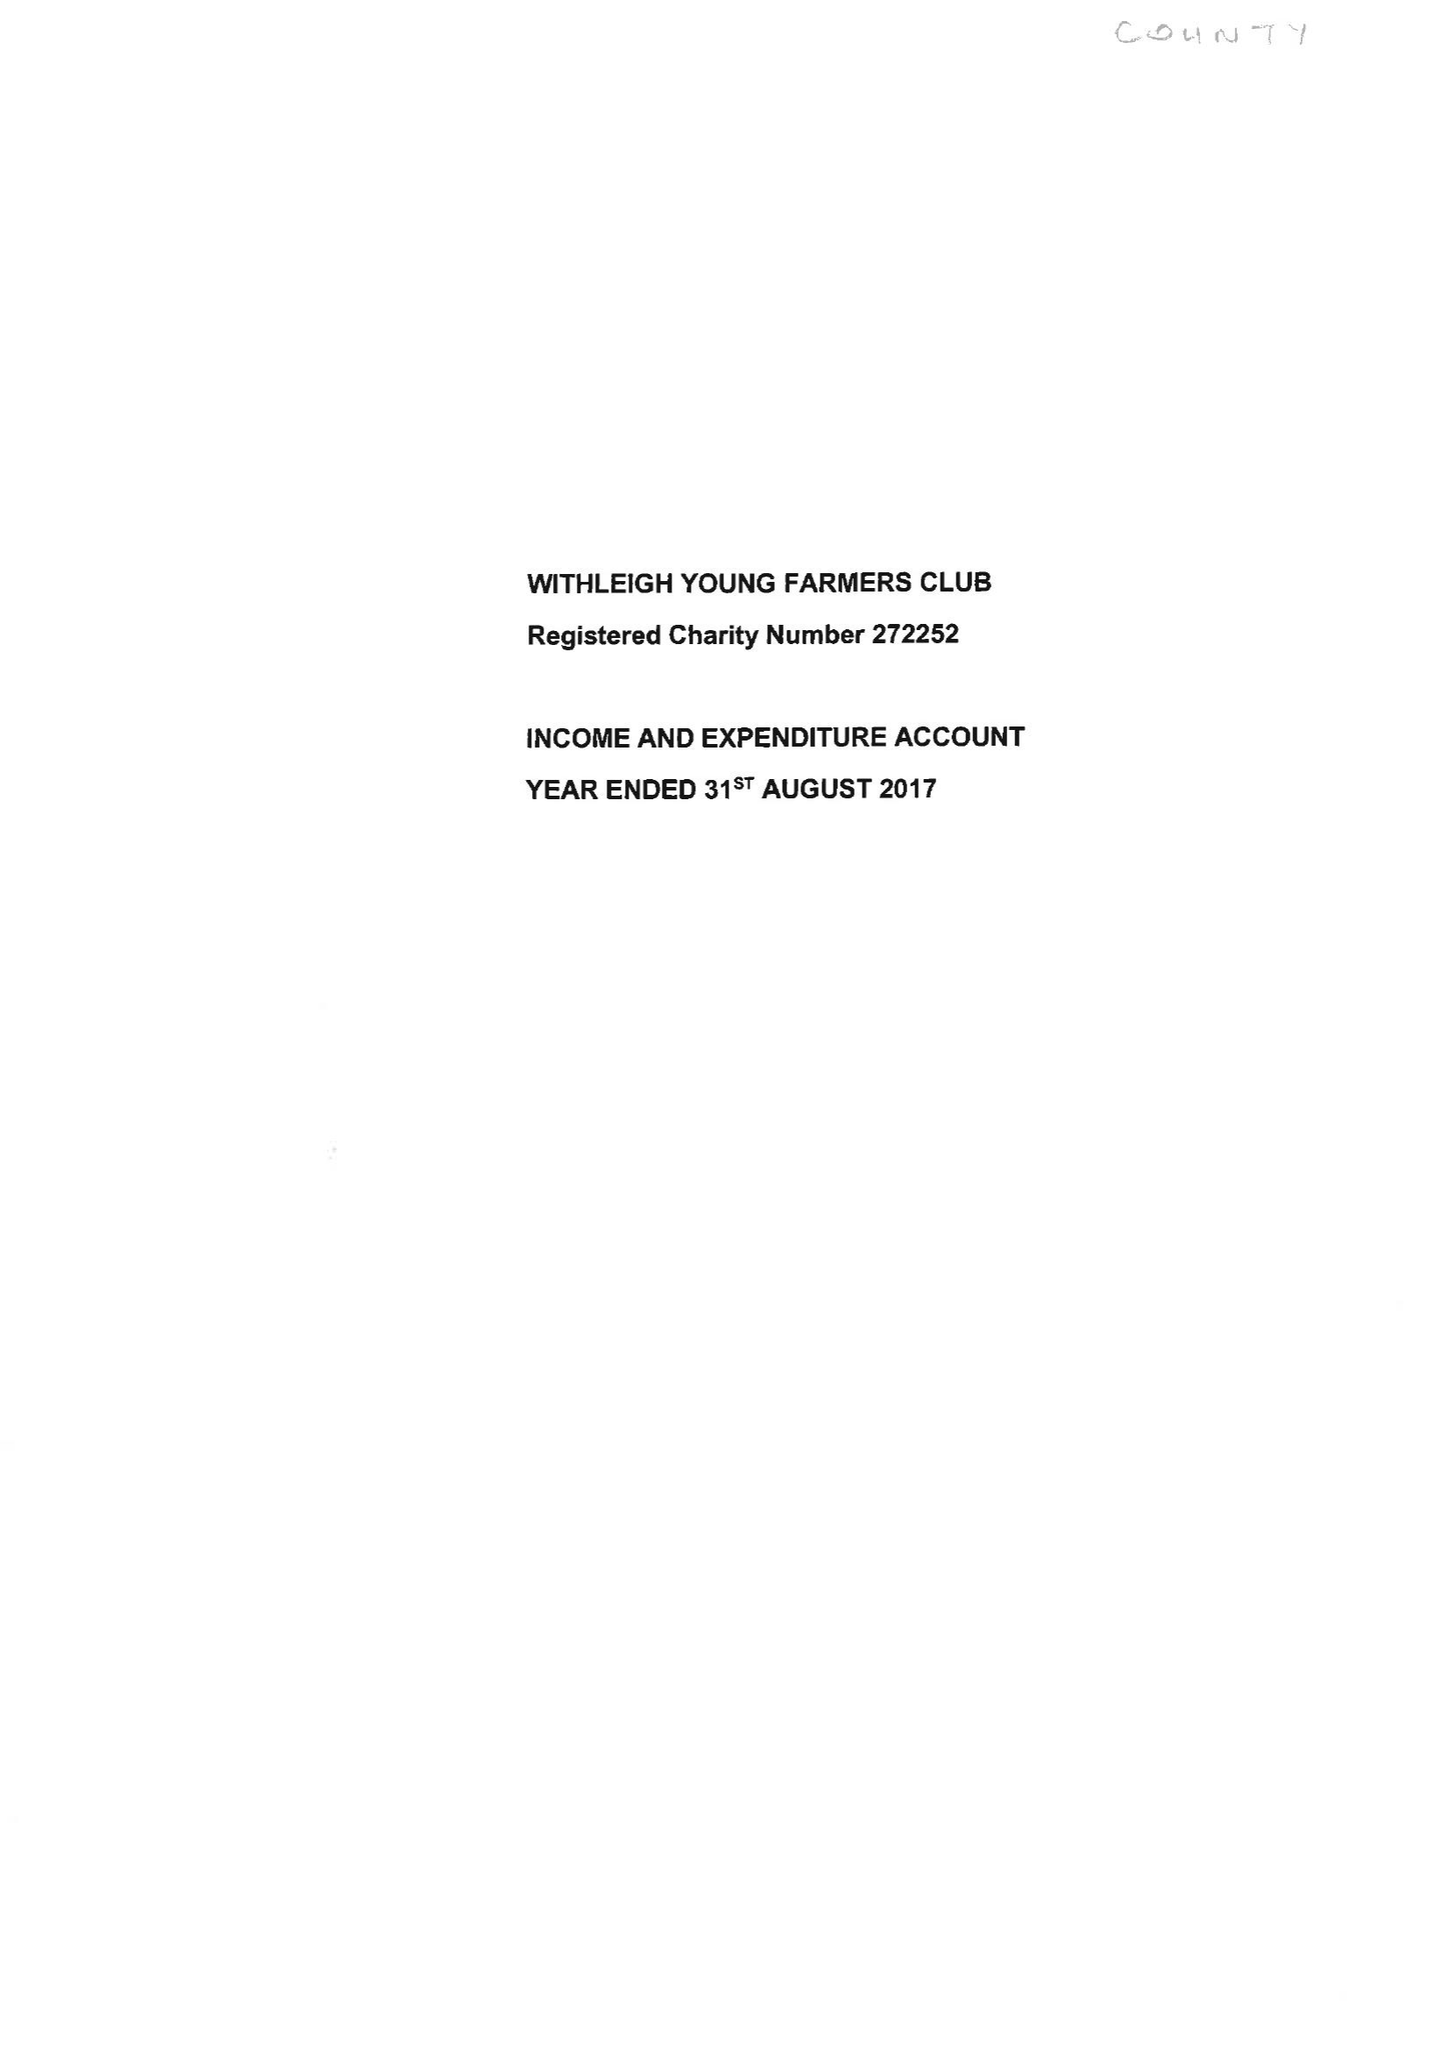What is the value for the address__postcode?
Answer the question using a single word or phrase. EX6 6JH 